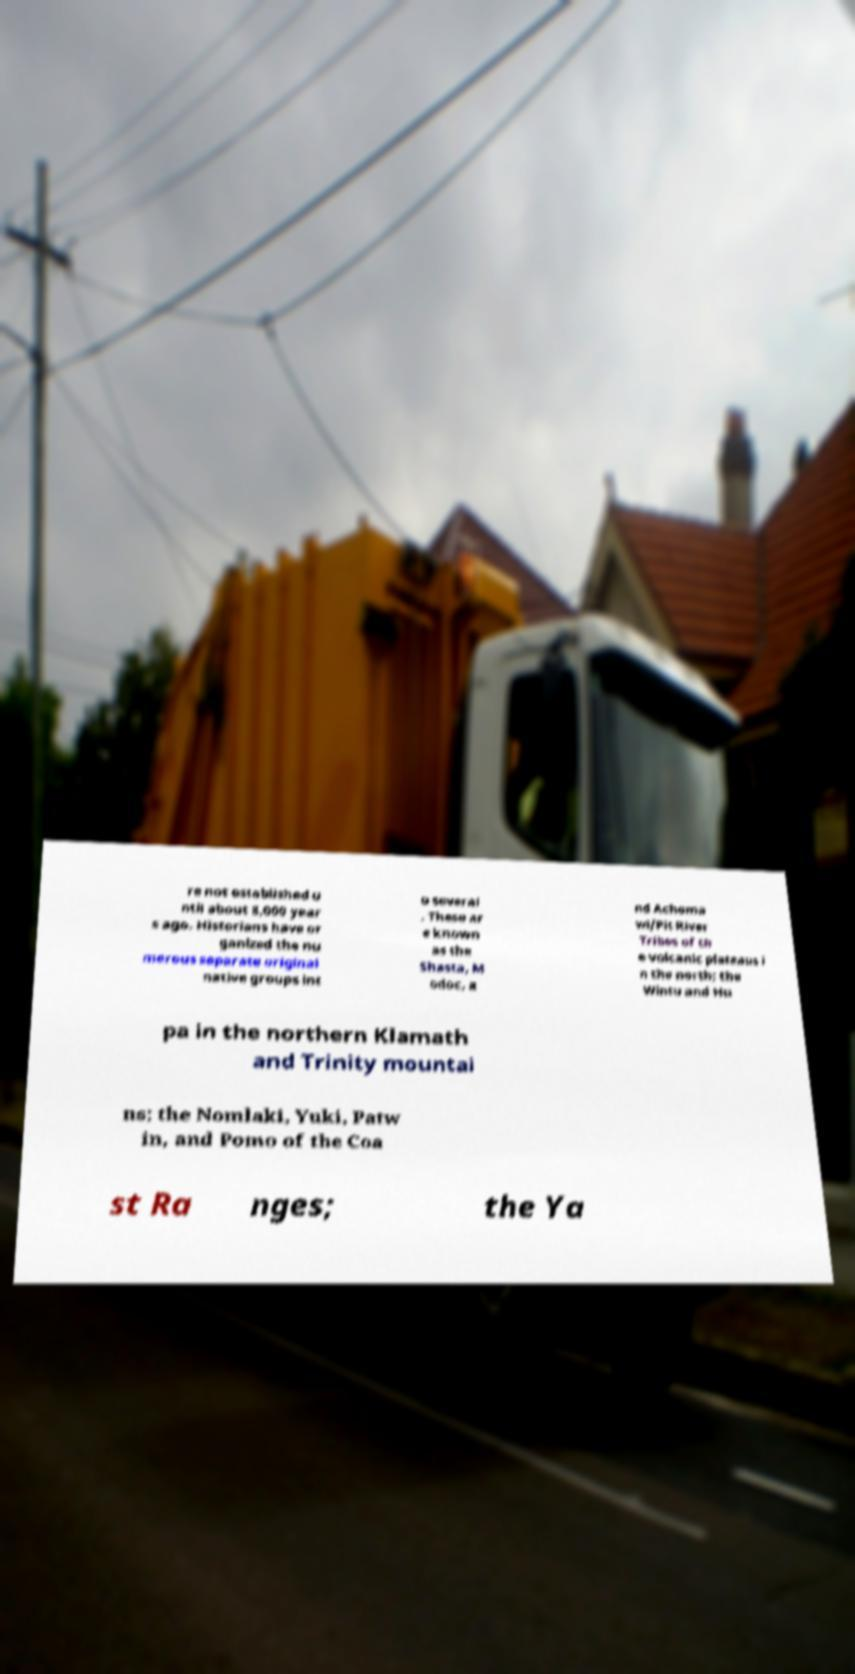There's text embedded in this image that I need extracted. Can you transcribe it verbatim? re not established u ntil about 8,000 year s ago. Historians have or ganized the nu merous separate original native groups int o several . These ar e known as the Shasta, M odoc, a nd Achoma wi/Pit River Tribes of th e volcanic plateaus i n the north; the Wintu and Hu pa in the northern Klamath and Trinity mountai ns; the Nomlaki, Yuki, Patw in, and Pomo of the Coa st Ra nges; the Ya 